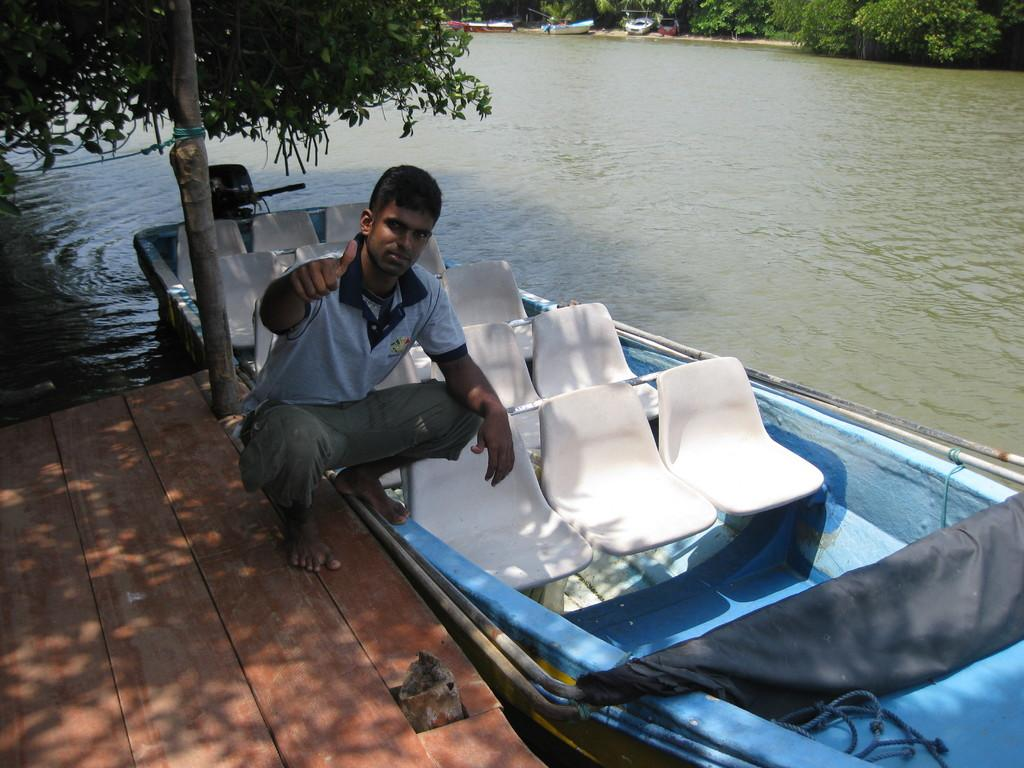What is the person in the image standing on? The person is on a wooden path in the image. What can be seen floating in the water? There is a boat in the water in the image. What type of natural environment is visible in the image? There are trees and water visible in the image. What is the surface that the person is standing on made of? The wooden path is made of wood. What else is present in the image besides the person and the boat? There are vehicles and the ground visible in the image. What type of ball is being used to play a game in the image? There is no ball present in the image; it features a person on a wooden path, a boat, water, trees, the ground, and vehicles. 